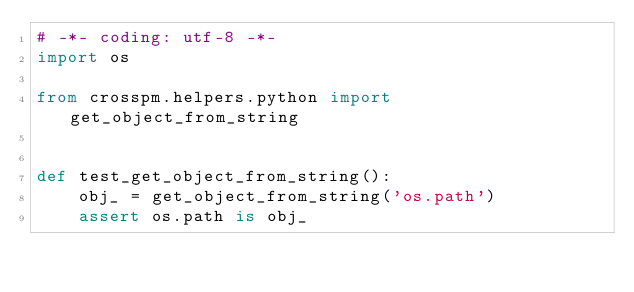<code> <loc_0><loc_0><loc_500><loc_500><_Python_># -*- coding: utf-8 -*-
import os

from crosspm.helpers.python import get_object_from_string


def test_get_object_from_string():
    obj_ = get_object_from_string('os.path')
    assert os.path is obj_
</code> 